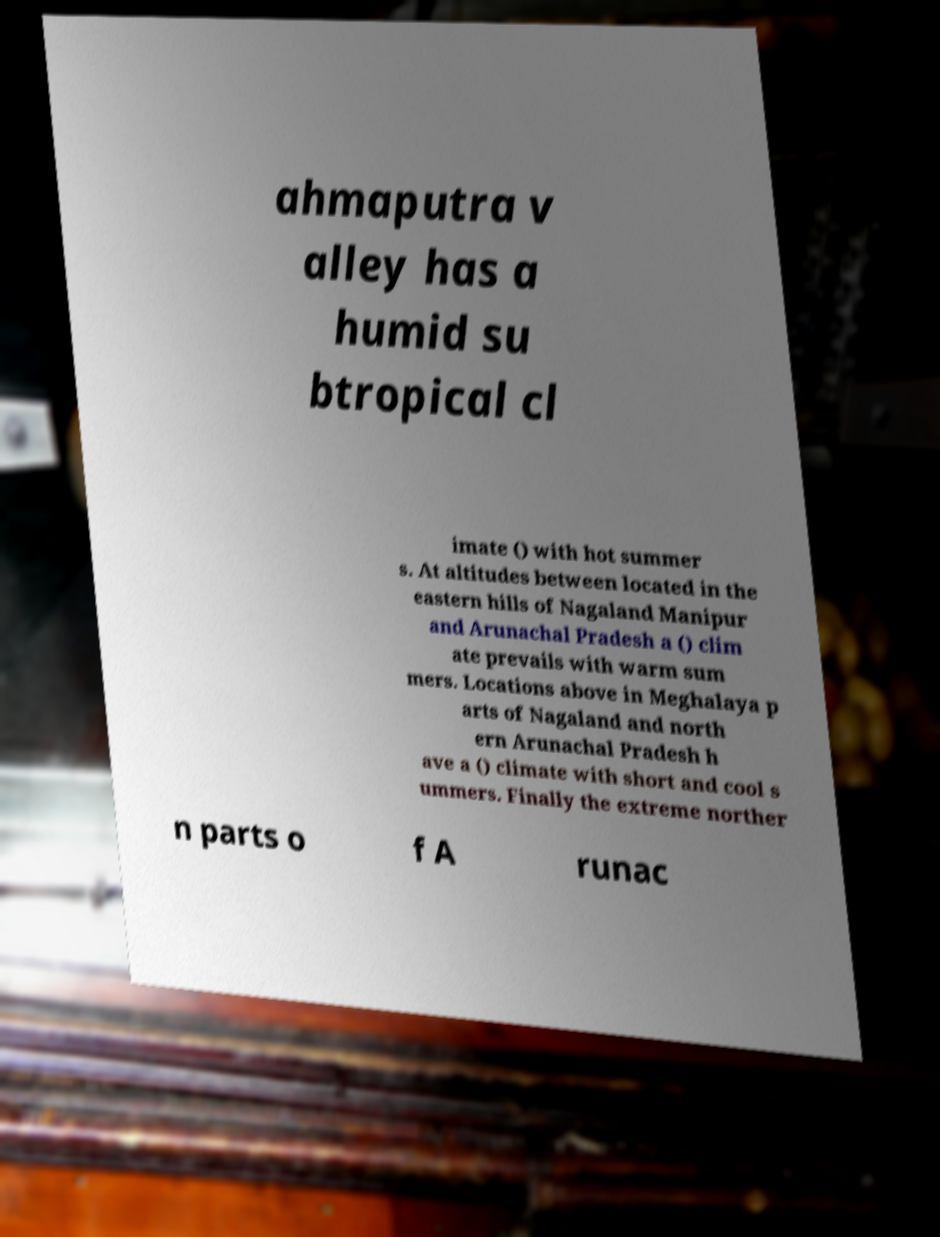Please identify and transcribe the text found in this image. ahmaputra v alley has a humid su btropical cl imate () with hot summer s. At altitudes between located in the eastern hills of Nagaland Manipur and Arunachal Pradesh a () clim ate prevails with warm sum mers. Locations above in Meghalaya p arts of Nagaland and north ern Arunachal Pradesh h ave a () climate with short and cool s ummers. Finally the extreme norther n parts o f A runac 